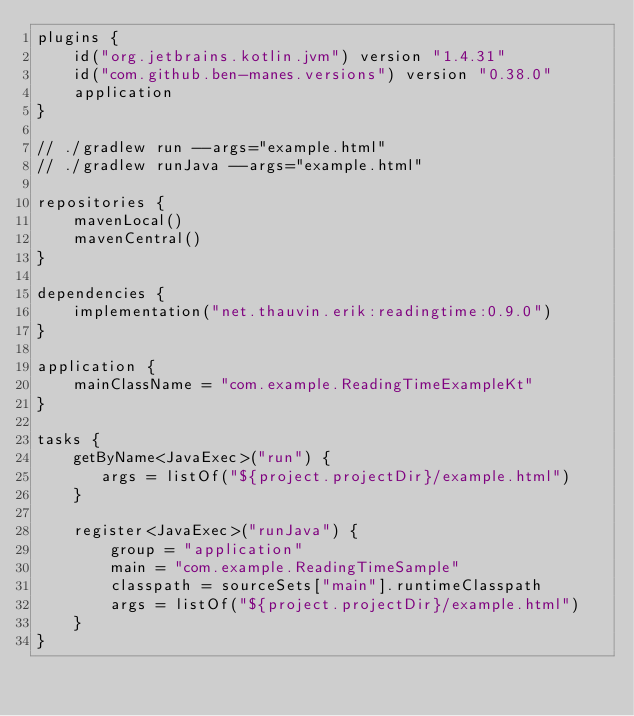<code> <loc_0><loc_0><loc_500><loc_500><_Kotlin_>plugins {
    id("org.jetbrains.kotlin.jvm") version "1.4.31"
    id("com.github.ben-manes.versions") version "0.38.0"
    application
}

// ./gradlew run --args="example.html"
// ./gradlew runJava --args="example.html"

repositories {
    mavenLocal()
    mavenCentral()
}

dependencies {
    implementation("net.thauvin.erik:readingtime:0.9.0")
}

application {
    mainClassName = "com.example.ReadingTimeExampleKt"
}

tasks {
    getByName<JavaExec>("run") {
       args = listOf("${project.projectDir}/example.html")
    }

    register<JavaExec>("runJava") {
        group = "application"
        main = "com.example.ReadingTimeSample"
        classpath = sourceSets["main"].runtimeClasspath
        args = listOf("${project.projectDir}/example.html")
    }
}
</code> 